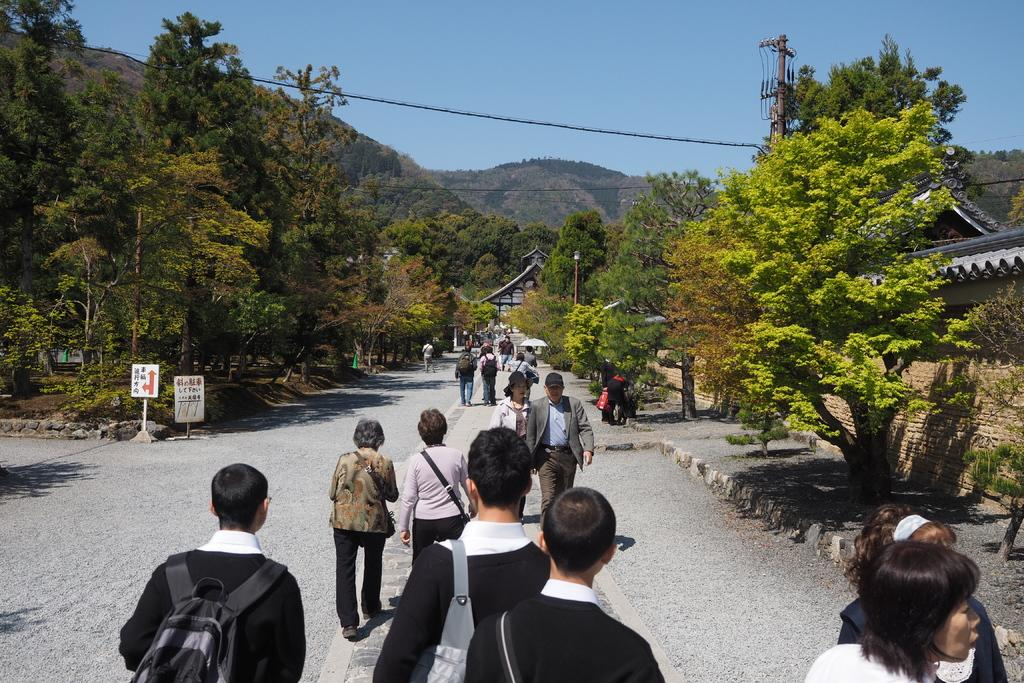What are the people in the image doing? The people in the image are walking on the road. What are the people carrying while walking? The people are carrying bags. What can be seen on either side of the road? There are trees on either side of the road. What is visible in the background of the image? In the background, there are hills covered with trees, and the sky is visible above the hills. Where is the doctor's office located in the image? There is no doctor's office present in the image. What date is marked on the calendar in the image? There is no calendar present in the image. 